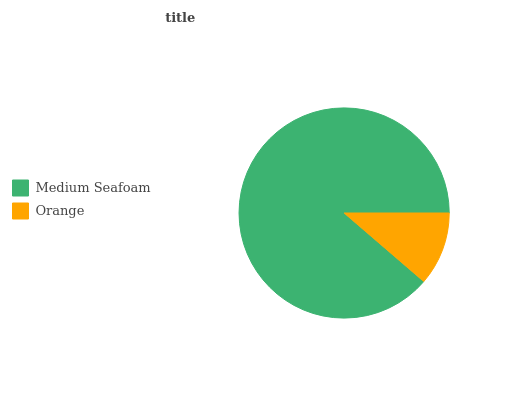Is Orange the minimum?
Answer yes or no. Yes. Is Medium Seafoam the maximum?
Answer yes or no. Yes. Is Orange the maximum?
Answer yes or no. No. Is Medium Seafoam greater than Orange?
Answer yes or no. Yes. Is Orange less than Medium Seafoam?
Answer yes or no. Yes. Is Orange greater than Medium Seafoam?
Answer yes or no. No. Is Medium Seafoam less than Orange?
Answer yes or no. No. Is Medium Seafoam the high median?
Answer yes or no. Yes. Is Orange the low median?
Answer yes or no. Yes. Is Orange the high median?
Answer yes or no. No. Is Medium Seafoam the low median?
Answer yes or no. No. 